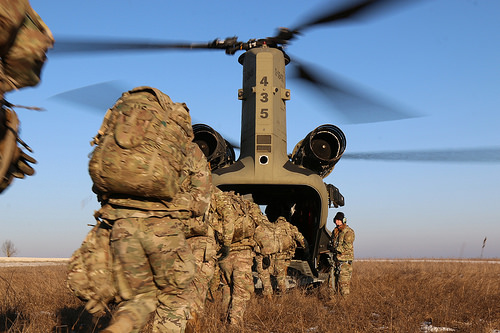<image>
Can you confirm if the backpack is on the helicopter? No. The backpack is not positioned on the helicopter. They may be near each other, but the backpack is not supported by or resting on top of the helicopter. 